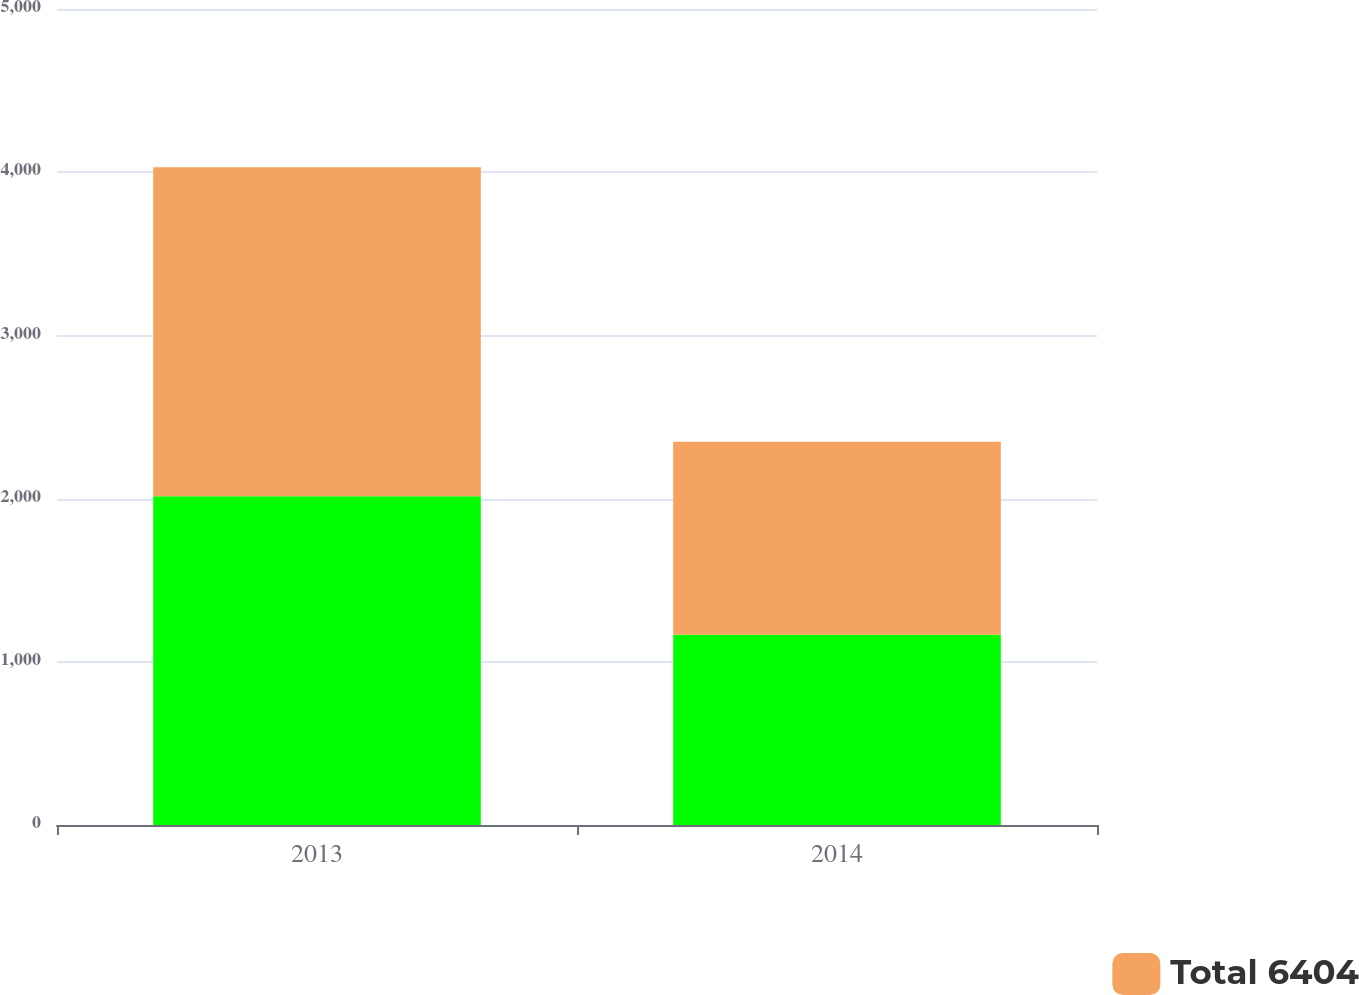<chart> <loc_0><loc_0><loc_500><loc_500><stacked_bar_chart><ecel><fcel>2013<fcel>2014<nl><fcel>nan<fcel>2014<fcel>1165<nl><fcel>Total 6404<fcel>2017<fcel>1184<nl></chart> 